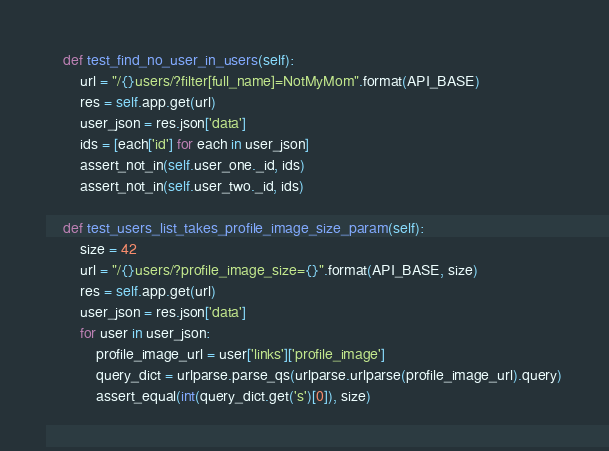Convert code to text. <code><loc_0><loc_0><loc_500><loc_500><_Python_>    def test_find_no_user_in_users(self):
        url = "/{}users/?filter[full_name]=NotMyMom".format(API_BASE)
        res = self.app.get(url)
        user_json = res.json['data']
        ids = [each['id'] for each in user_json]
        assert_not_in(self.user_one._id, ids)
        assert_not_in(self.user_two._id, ids)

    def test_users_list_takes_profile_image_size_param(self):
        size = 42
        url = "/{}users/?profile_image_size={}".format(API_BASE, size)
        res = self.app.get(url)
        user_json = res.json['data']
        for user in user_json:
            profile_image_url = user['links']['profile_image']
            query_dict = urlparse.parse_qs(urlparse.urlparse(profile_image_url).query)
            assert_equal(int(query_dict.get('s')[0]), size)

</code> 